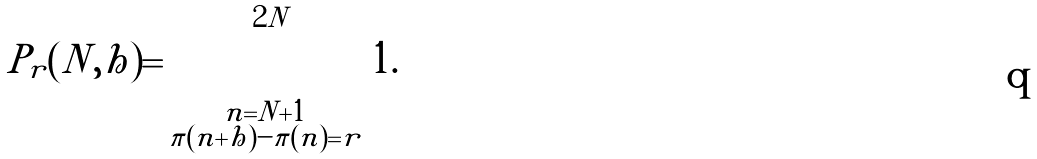Convert formula to latex. <formula><loc_0><loc_0><loc_500><loc_500>P _ { r } ( N , h ) = \sum _ { \substack { n = N + 1 \\ \pi ( n + h ) - \pi ( n ) = r } } ^ { 2 N } 1 .</formula> 